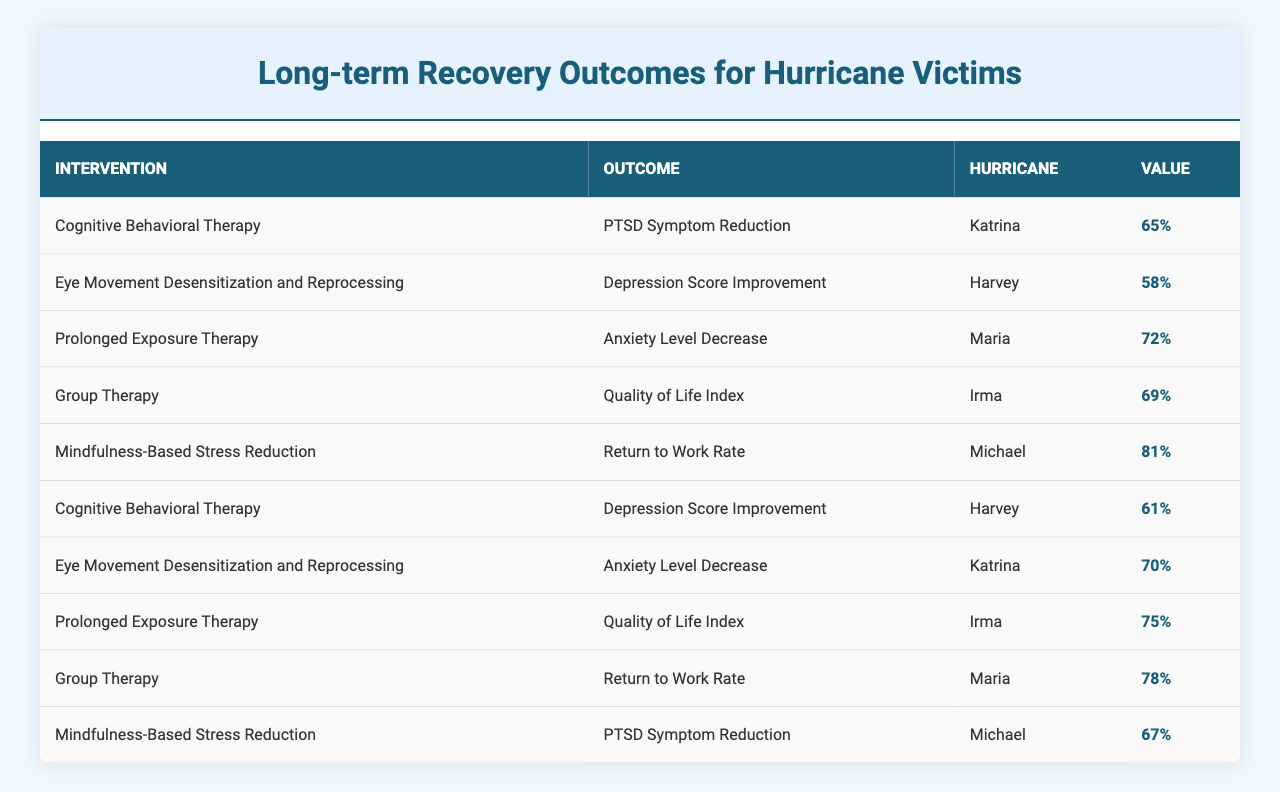What is the highest value for PTSD Symptom Reduction? The highest value for PTSD Symptom Reduction can be found by looking at the relevant rows in the table. The only intervention listed for this outcome is Cognitive Behavioral Therapy with a value of 65%.
Answer: 65% Which hurricane had the lowest Depression Score Improvement? By examining the entries under Depression Score Improvement, the value for Eye Movement Desensitization and Reprocessing during Hurricane Harvey is 58%, which is the lowest value among the relevant outcomes in the table.
Answer: 58% Is there an intervention that had a Return to Work Rate higher than 75%? Looking for the value of Return to Work Rate, we can see from the table that Mindfulness-Based Stress Reduction has a value of 81%, which is indeed higher than 75%.
Answer: Yes What is the average Anxiety Level Decrease value from the two interventions? The value for Anxiety Level Decrease from Eye Movement Desensitization and Reprocessing for Hurricane Katrina is 70%, and from Prolonged Exposure Therapy for Hurricane Maria is 72%. The average is calculated as (70 + 72) / 2 = 71%.
Answer: 71% Which intervention led to the highest Quality of Life Index? To identify the highest Quality of Life Index, we look at the relevant entries and find that Prolonged Exposure Therapy for Hurricane Irma had a value of 75%, which is higher than the value of 69% from Group Therapy for Hurricane Irma.
Answer: 75% Total value of PTSD Symptom Reduction and Return to Work Rate combined? We can see that the value for PTSD Symptom Reduction via Cognitive Behavioral Therapy for Hurricane Katrina is 65%, and the value for Mindfulness-Based Stress Reduction for Return to Work Rate in Hurricane Michael is 81%. Adding these together gives us 65 + 81 = 146%.
Answer: 146% Do all interventions perform equally well across all hurricanes? By reviewing the table, we see that different interventions show varying values across hurricanes. For example, Group Therapy has different quality of life indices depending on the hurricane, indicating that they do not perform equally well.
Answer: No What intervention has the highest overall impact based on all values listed? To determine the intervention with the highest overall impact, we could consider adding up the values across all related outcomes. For example, Cognitive Behavioral Therapy has two contributions: 65% for PTSD and 61% for Depression, totaling 126%. Calculating for others would reveal their contributions, but initial observation shows that Mindfulness-Based Stress Reduction has a substantial overall impact with a high Return to Work Rate and PTSD Symptom Reduction, making it quite significant. Detailed calculations would be needed for a conclusive answer.
Answer: Need calculation for exact totals based on gathered data 